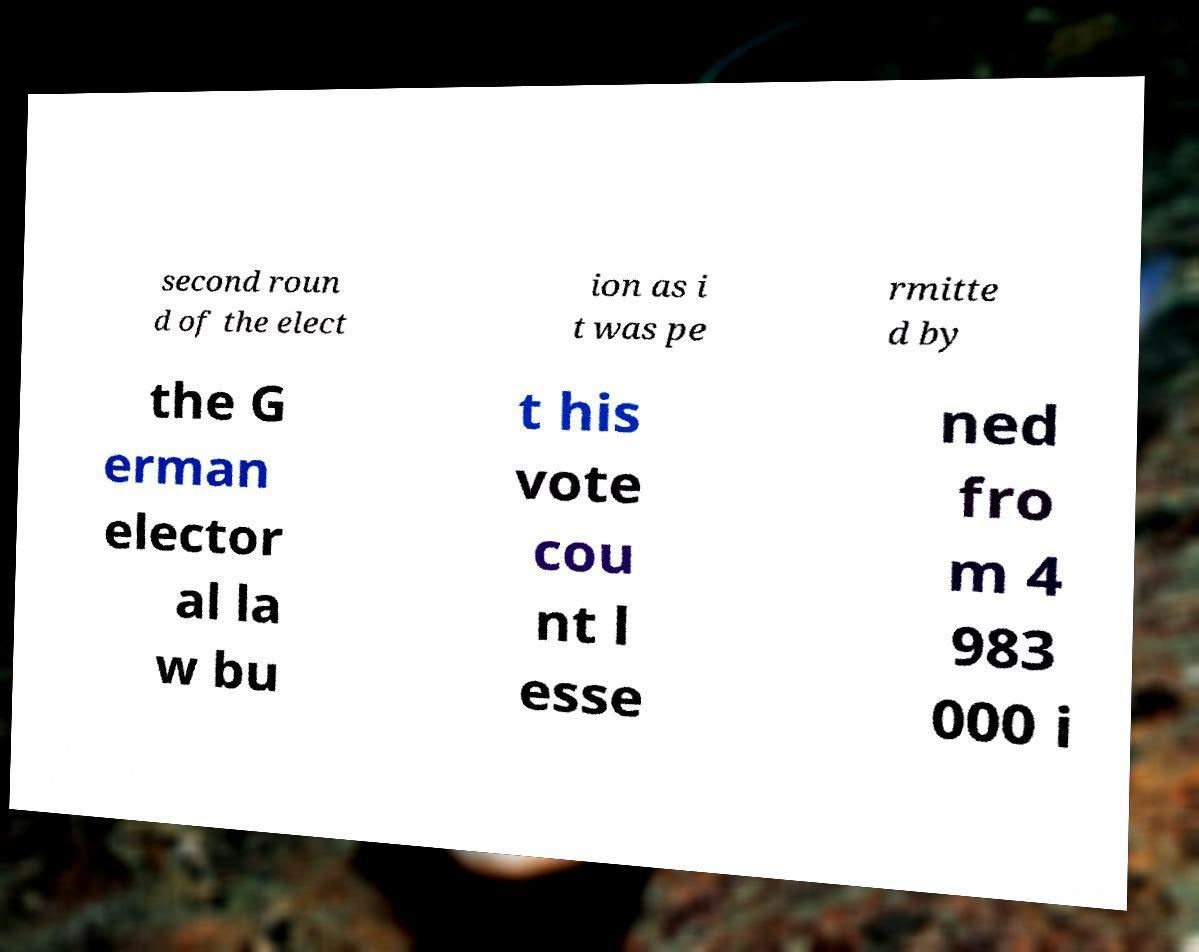I need the written content from this picture converted into text. Can you do that? second roun d of the elect ion as i t was pe rmitte d by the G erman elector al la w bu t his vote cou nt l esse ned fro m 4 983 000 i 